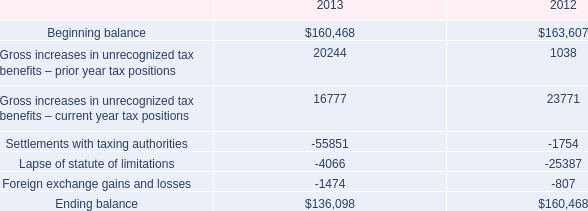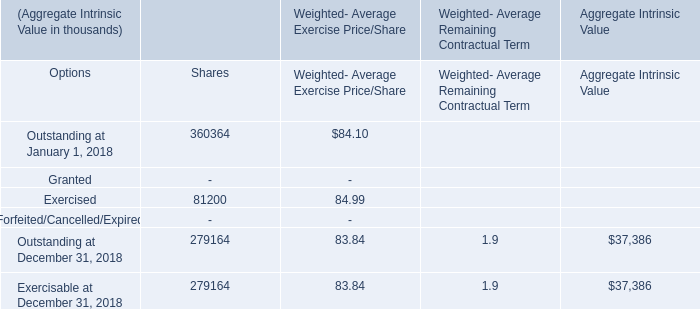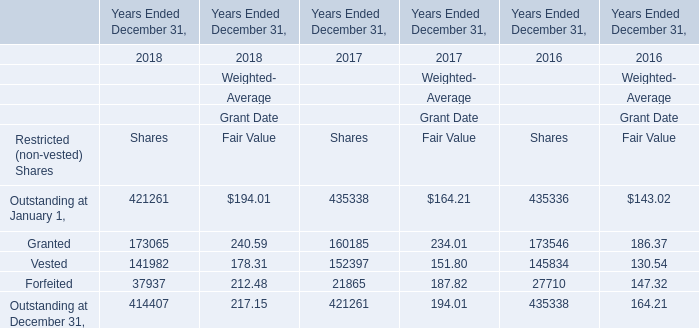What will Granted for Weighted-Average Grant Date Fair Value reach in 2019 if it continues to grow at its current rate? 
Computations: (240.59 * (1 + ((240.59 - 234.01) / 234.01)))
Answer: 247.35502. 